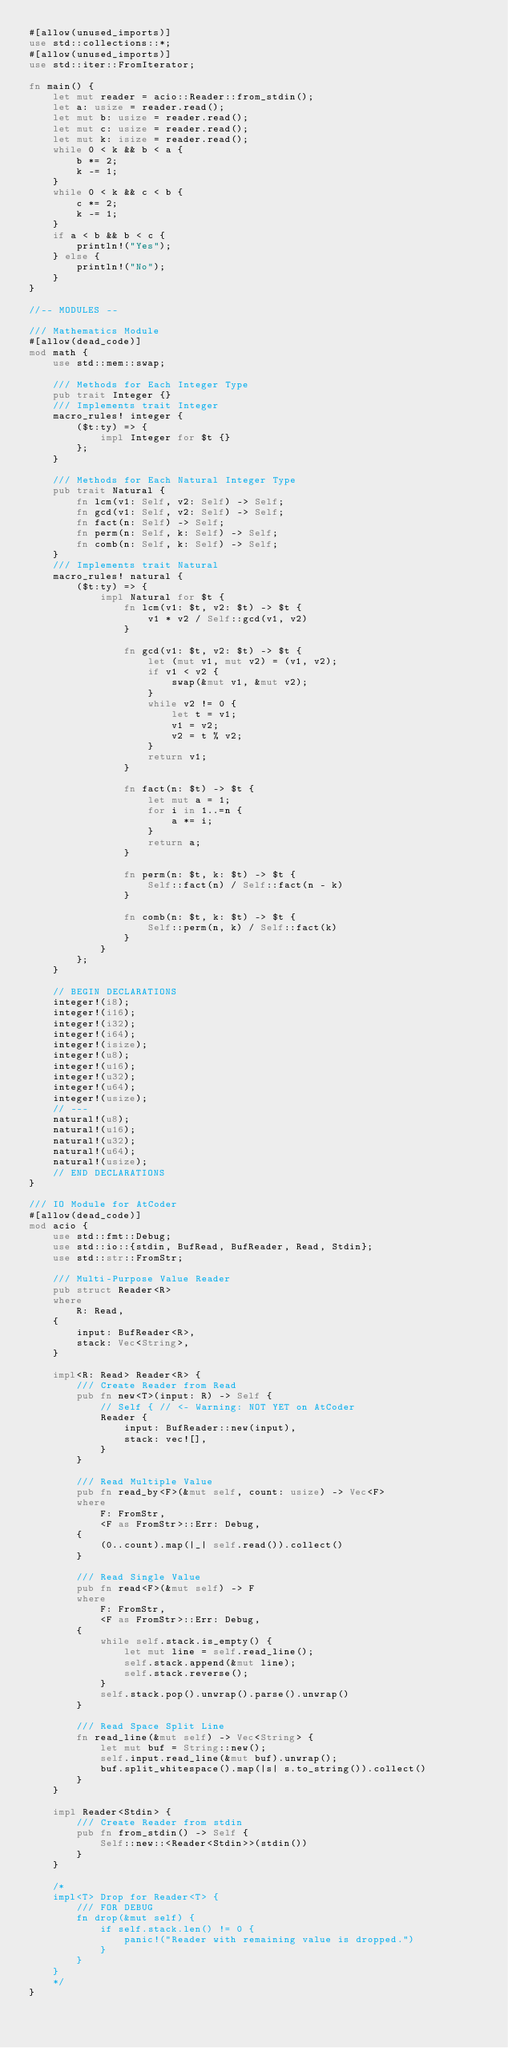<code> <loc_0><loc_0><loc_500><loc_500><_Rust_>#[allow(unused_imports)]
use std::collections::*;
#[allow(unused_imports)]
use std::iter::FromIterator;

fn main() {
    let mut reader = acio::Reader::from_stdin();
    let a: usize = reader.read();
    let mut b: usize = reader.read();
    let mut c: usize = reader.read();
    let mut k: isize = reader.read();
    while 0 < k && b < a {
        b *= 2;
        k -= 1;
    }
    while 0 < k && c < b {
        c *= 2;
        k -= 1;
    }
    if a < b && b < c {
        println!("Yes");
    } else {
        println!("No");
    }
}

//-- MODULES --

/// Mathematics Module
#[allow(dead_code)]
mod math {
    use std::mem::swap;

    /// Methods for Each Integer Type
    pub trait Integer {}
    /// Implements trait Integer
    macro_rules! integer {
        ($t:ty) => {
            impl Integer for $t {}
        };
    }

    /// Methods for Each Natural Integer Type
    pub trait Natural {
        fn lcm(v1: Self, v2: Self) -> Self;
        fn gcd(v1: Self, v2: Self) -> Self;
        fn fact(n: Self) -> Self;
        fn perm(n: Self, k: Self) -> Self;
        fn comb(n: Self, k: Self) -> Self;
    }
    /// Implements trait Natural
    macro_rules! natural {
        ($t:ty) => {
            impl Natural for $t {
                fn lcm(v1: $t, v2: $t) -> $t {
                    v1 * v2 / Self::gcd(v1, v2)
                }

                fn gcd(v1: $t, v2: $t) -> $t {
                    let (mut v1, mut v2) = (v1, v2);
                    if v1 < v2 {
                        swap(&mut v1, &mut v2);
                    }
                    while v2 != 0 {
                        let t = v1;
                        v1 = v2;
                        v2 = t % v2;
                    }
                    return v1;
                }

                fn fact(n: $t) -> $t {
                    let mut a = 1;
                    for i in 1..=n {
                        a *= i;
                    }
                    return a;
                }

                fn perm(n: $t, k: $t) -> $t {
                    Self::fact(n) / Self::fact(n - k)
                }

                fn comb(n: $t, k: $t) -> $t {
                    Self::perm(n, k) / Self::fact(k)
                }
            }
        };
    }

    // BEGIN DECLARATIONS
    integer!(i8);
    integer!(i16);
    integer!(i32);
    integer!(i64);
    integer!(isize);
    integer!(u8);
    integer!(u16);
    integer!(u32);
    integer!(u64);
    integer!(usize);
    // ---
    natural!(u8);
    natural!(u16);
    natural!(u32);
    natural!(u64);
    natural!(usize);
    // END DECLARATIONS
}

/// IO Module for AtCoder
#[allow(dead_code)]
mod acio {
    use std::fmt::Debug;
    use std::io::{stdin, BufRead, BufReader, Read, Stdin};
    use std::str::FromStr;

    /// Multi-Purpose Value Reader
    pub struct Reader<R>
    where
        R: Read,
    {
        input: BufReader<R>,
        stack: Vec<String>,
    }

    impl<R: Read> Reader<R> {
        /// Create Reader from Read
        pub fn new<T>(input: R) -> Self {
            // Self { // <- Warning: NOT YET on AtCoder
            Reader {
                input: BufReader::new(input),
                stack: vec![],
            }
        }

        /// Read Multiple Value
        pub fn read_by<F>(&mut self, count: usize) -> Vec<F>
        where
            F: FromStr,
            <F as FromStr>::Err: Debug,
        {
            (0..count).map(|_| self.read()).collect()
        }

        /// Read Single Value
        pub fn read<F>(&mut self) -> F
        where
            F: FromStr,
            <F as FromStr>::Err: Debug,
        {
            while self.stack.is_empty() {
                let mut line = self.read_line();
                self.stack.append(&mut line);
                self.stack.reverse();
            }
            self.stack.pop().unwrap().parse().unwrap()
        }

        /// Read Space Split Line
        fn read_line(&mut self) -> Vec<String> {
            let mut buf = String::new();
            self.input.read_line(&mut buf).unwrap();
            buf.split_whitespace().map(|s| s.to_string()).collect()
        }
    }

    impl Reader<Stdin> {
        /// Create Reader from stdin
        pub fn from_stdin() -> Self {
            Self::new::<Reader<Stdin>>(stdin())
        }
    }

    /*
    impl<T> Drop for Reader<T> {
        /// FOR DEBUG
        fn drop(&mut self) {
            if self.stack.len() != 0 {
                panic!("Reader with remaining value is dropped.")
            }
        }
    }
    */
}
</code> 